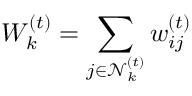Convert formula to latex. <formula><loc_0><loc_0><loc_500><loc_500>W _ { k } ^ { ( t ) } = \sum _ { j \in \mathcal { N } _ { k } ^ { ( t ) } } w _ { i j } ^ { ( t ) }</formula> 